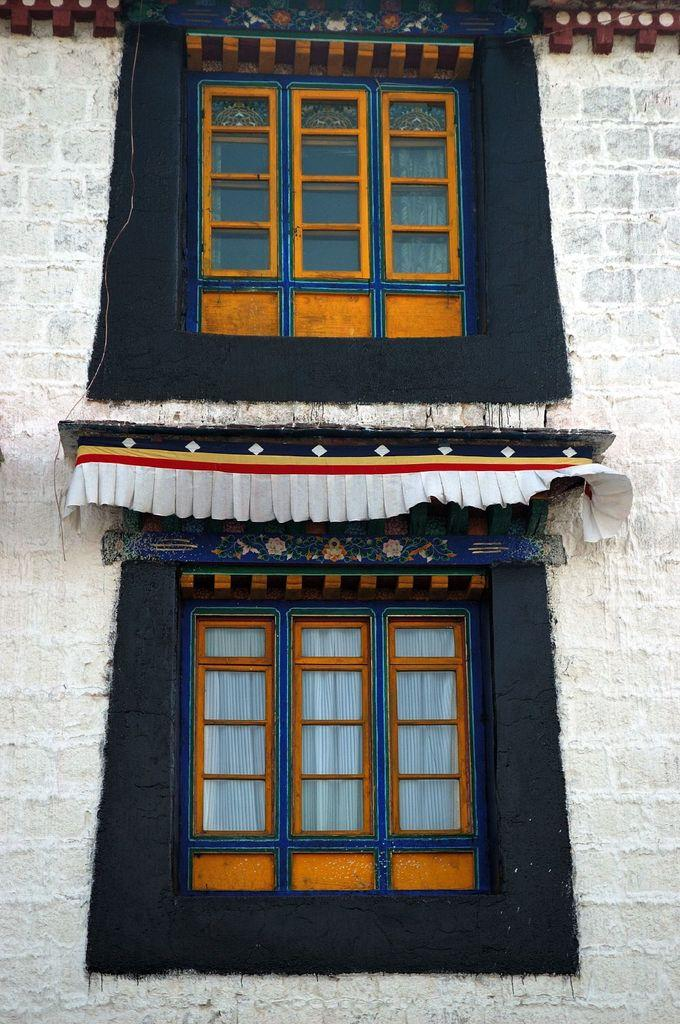How many windows are visible in the image? There are two windows in the image. What else can be seen in the image besides the windows? There is a wall in the image. What type of butter is being used to answer questions in the image? There is no butter present in the image, and no one is answering questions. 